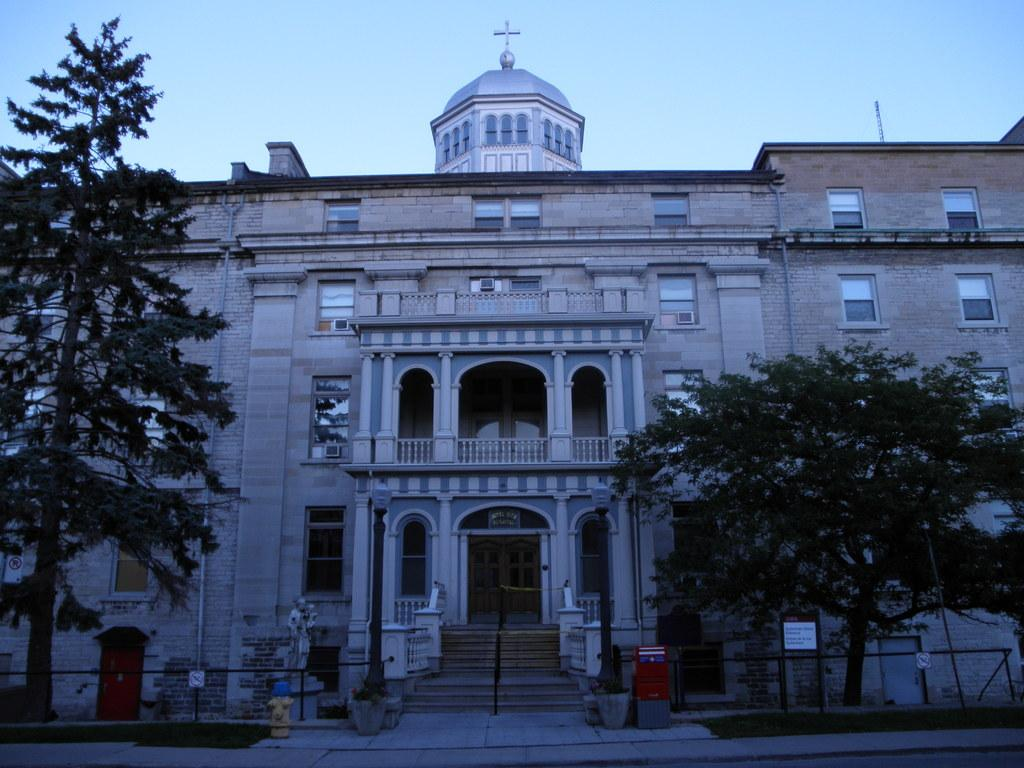What type of natural elements can be seen in the image? There are trees in the image. What architectural feature is present in the image? There is a railing in the image. What can be seen in the background of the image? There is a building in the background of the image. What color is the sky in the image? The sky is blue in the image. What type of toys can be seen on the ground in the image? There are no toys present in the image. How much sugar is visible in the image? There is no sugar visible in the image. 